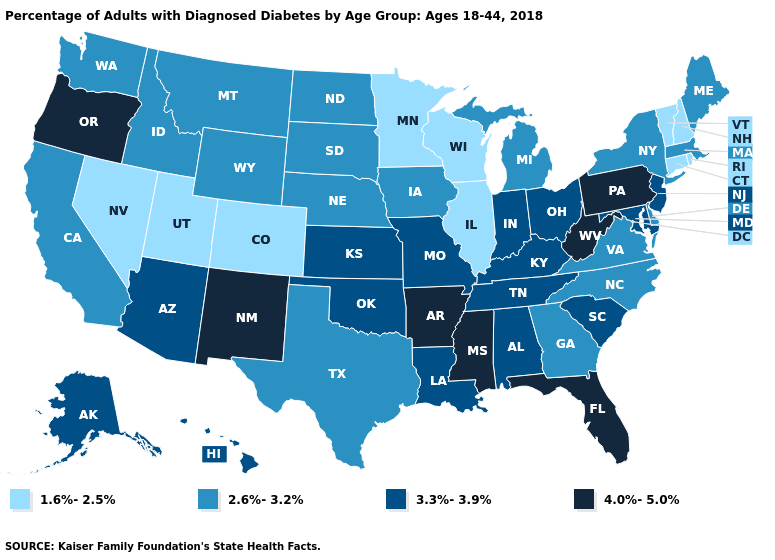Which states have the highest value in the USA?
Give a very brief answer. Arkansas, Florida, Mississippi, New Mexico, Oregon, Pennsylvania, West Virginia. Name the states that have a value in the range 3.3%-3.9%?
Be succinct. Alabama, Alaska, Arizona, Hawaii, Indiana, Kansas, Kentucky, Louisiana, Maryland, Missouri, New Jersey, Ohio, Oklahoma, South Carolina, Tennessee. Name the states that have a value in the range 4.0%-5.0%?
Answer briefly. Arkansas, Florida, Mississippi, New Mexico, Oregon, Pennsylvania, West Virginia. What is the highest value in the USA?
Concise answer only. 4.0%-5.0%. Name the states that have a value in the range 1.6%-2.5%?
Be succinct. Colorado, Connecticut, Illinois, Minnesota, Nevada, New Hampshire, Rhode Island, Utah, Vermont, Wisconsin. What is the value of Maryland?
Concise answer only. 3.3%-3.9%. What is the value of West Virginia?
Write a very short answer. 4.0%-5.0%. What is the value of Illinois?
Answer briefly. 1.6%-2.5%. What is the highest value in the USA?
Keep it brief. 4.0%-5.0%. What is the value of Washington?
Concise answer only. 2.6%-3.2%. Name the states that have a value in the range 4.0%-5.0%?
Quick response, please. Arkansas, Florida, Mississippi, New Mexico, Oregon, Pennsylvania, West Virginia. Name the states that have a value in the range 4.0%-5.0%?
Short answer required. Arkansas, Florida, Mississippi, New Mexico, Oregon, Pennsylvania, West Virginia. Does Virginia have the lowest value in the USA?
Answer briefly. No. What is the lowest value in the USA?
Keep it brief. 1.6%-2.5%. Does Oregon have the highest value in the USA?
Concise answer only. Yes. 